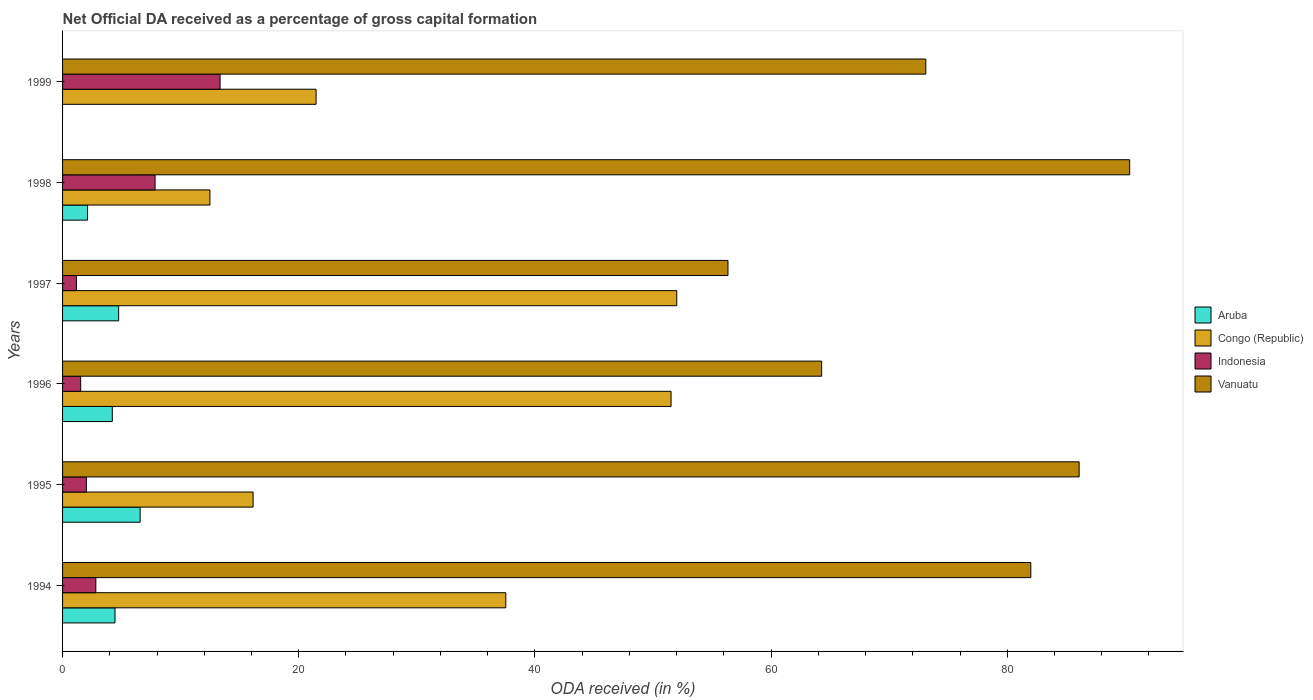How many bars are there on the 4th tick from the bottom?
Provide a short and direct response. 4. In how many cases, is the number of bars for a given year not equal to the number of legend labels?
Your answer should be compact. 1. What is the net ODA received in Indonesia in 1995?
Your answer should be very brief. 2.02. Across all years, what is the maximum net ODA received in Vanuatu?
Ensure brevity in your answer.  90.36. Across all years, what is the minimum net ODA received in Indonesia?
Provide a short and direct response. 1.18. What is the total net ODA received in Aruba in the graph?
Your response must be concise. 22.09. What is the difference between the net ODA received in Aruba in 1995 and that in 1996?
Your answer should be very brief. 2.36. What is the difference between the net ODA received in Aruba in 1995 and the net ODA received in Vanuatu in 1997?
Provide a succinct answer. -49.78. What is the average net ODA received in Vanuatu per year?
Ensure brevity in your answer.  75.36. In the year 1995, what is the difference between the net ODA received in Congo (Republic) and net ODA received in Vanuatu?
Give a very brief answer. -69.95. In how many years, is the net ODA received in Indonesia greater than 52 %?
Provide a succinct answer. 0. What is the ratio of the net ODA received in Congo (Republic) in 1995 to that in 1999?
Keep it short and to the point. 0.75. Is the net ODA received in Vanuatu in 1994 less than that in 1997?
Your answer should be very brief. No. Is the difference between the net ODA received in Congo (Republic) in 1994 and 1995 greater than the difference between the net ODA received in Vanuatu in 1994 and 1995?
Your answer should be compact. Yes. What is the difference between the highest and the second highest net ODA received in Vanuatu?
Make the answer very short. 4.28. What is the difference between the highest and the lowest net ODA received in Congo (Republic)?
Your response must be concise. 39.53. In how many years, is the net ODA received in Aruba greater than the average net ODA received in Aruba taken over all years?
Provide a succinct answer. 4. Is it the case that in every year, the sum of the net ODA received in Vanuatu and net ODA received in Aruba is greater than the net ODA received in Congo (Republic)?
Your response must be concise. Yes. Are all the bars in the graph horizontal?
Offer a very short reply. Yes. How many years are there in the graph?
Offer a very short reply. 6. Does the graph contain any zero values?
Give a very brief answer. Yes. Where does the legend appear in the graph?
Make the answer very short. Center right. How are the legend labels stacked?
Make the answer very short. Vertical. What is the title of the graph?
Your answer should be compact. Net Official DA received as a percentage of gross capital formation. What is the label or title of the X-axis?
Make the answer very short. ODA received (in %). What is the label or title of the Y-axis?
Your answer should be compact. Years. What is the ODA received (in %) of Aruba in 1994?
Provide a succinct answer. 4.44. What is the ODA received (in %) in Congo (Republic) in 1994?
Ensure brevity in your answer.  37.53. What is the ODA received (in %) in Indonesia in 1994?
Provide a succinct answer. 2.82. What is the ODA received (in %) in Vanuatu in 1994?
Make the answer very short. 81.99. What is the ODA received (in %) in Aruba in 1995?
Provide a succinct answer. 6.57. What is the ODA received (in %) of Congo (Republic) in 1995?
Offer a very short reply. 16.13. What is the ODA received (in %) in Indonesia in 1995?
Your response must be concise. 2.02. What is the ODA received (in %) in Vanuatu in 1995?
Offer a terse response. 86.09. What is the ODA received (in %) of Aruba in 1996?
Offer a terse response. 4.21. What is the ODA received (in %) of Congo (Republic) in 1996?
Make the answer very short. 51.53. What is the ODA received (in %) in Indonesia in 1996?
Make the answer very short. 1.53. What is the ODA received (in %) in Vanuatu in 1996?
Give a very brief answer. 64.28. What is the ODA received (in %) of Aruba in 1997?
Make the answer very short. 4.75. What is the ODA received (in %) in Congo (Republic) in 1997?
Ensure brevity in your answer.  52.01. What is the ODA received (in %) of Indonesia in 1997?
Ensure brevity in your answer.  1.18. What is the ODA received (in %) in Vanuatu in 1997?
Your answer should be very brief. 56.35. What is the ODA received (in %) in Aruba in 1998?
Give a very brief answer. 2.12. What is the ODA received (in %) in Congo (Republic) in 1998?
Offer a very short reply. 12.48. What is the ODA received (in %) of Indonesia in 1998?
Ensure brevity in your answer.  7.83. What is the ODA received (in %) of Vanuatu in 1998?
Your answer should be compact. 90.36. What is the ODA received (in %) of Congo (Republic) in 1999?
Keep it short and to the point. 21.47. What is the ODA received (in %) of Indonesia in 1999?
Offer a very short reply. 13.34. What is the ODA received (in %) of Vanuatu in 1999?
Make the answer very short. 73.1. Across all years, what is the maximum ODA received (in %) in Aruba?
Provide a short and direct response. 6.57. Across all years, what is the maximum ODA received (in %) of Congo (Republic)?
Provide a short and direct response. 52.01. Across all years, what is the maximum ODA received (in %) of Indonesia?
Your answer should be very brief. 13.34. Across all years, what is the maximum ODA received (in %) of Vanuatu?
Give a very brief answer. 90.36. Across all years, what is the minimum ODA received (in %) of Aruba?
Your answer should be compact. 0. Across all years, what is the minimum ODA received (in %) in Congo (Republic)?
Your answer should be very brief. 12.48. Across all years, what is the minimum ODA received (in %) in Indonesia?
Ensure brevity in your answer.  1.18. Across all years, what is the minimum ODA received (in %) in Vanuatu?
Provide a short and direct response. 56.35. What is the total ODA received (in %) in Aruba in the graph?
Your response must be concise. 22.09. What is the total ODA received (in %) in Congo (Republic) in the graph?
Your response must be concise. 191.15. What is the total ODA received (in %) of Indonesia in the graph?
Your answer should be compact. 28.72. What is the total ODA received (in %) in Vanuatu in the graph?
Offer a terse response. 452.17. What is the difference between the ODA received (in %) of Aruba in 1994 and that in 1995?
Give a very brief answer. -2.13. What is the difference between the ODA received (in %) of Congo (Republic) in 1994 and that in 1995?
Keep it short and to the point. 21.4. What is the difference between the ODA received (in %) of Indonesia in 1994 and that in 1995?
Offer a terse response. 0.8. What is the difference between the ODA received (in %) of Vanuatu in 1994 and that in 1995?
Provide a short and direct response. -4.09. What is the difference between the ODA received (in %) in Aruba in 1994 and that in 1996?
Keep it short and to the point. 0.23. What is the difference between the ODA received (in %) of Congo (Republic) in 1994 and that in 1996?
Your answer should be compact. -13.99. What is the difference between the ODA received (in %) of Indonesia in 1994 and that in 1996?
Your answer should be compact. 1.28. What is the difference between the ODA received (in %) in Vanuatu in 1994 and that in 1996?
Your answer should be compact. 17.71. What is the difference between the ODA received (in %) in Aruba in 1994 and that in 1997?
Provide a succinct answer. -0.31. What is the difference between the ODA received (in %) in Congo (Republic) in 1994 and that in 1997?
Make the answer very short. -14.48. What is the difference between the ODA received (in %) of Indonesia in 1994 and that in 1997?
Provide a succinct answer. 1.64. What is the difference between the ODA received (in %) of Vanuatu in 1994 and that in 1997?
Offer a very short reply. 25.64. What is the difference between the ODA received (in %) in Aruba in 1994 and that in 1998?
Offer a very short reply. 2.32. What is the difference between the ODA received (in %) of Congo (Republic) in 1994 and that in 1998?
Give a very brief answer. 25.06. What is the difference between the ODA received (in %) in Indonesia in 1994 and that in 1998?
Provide a short and direct response. -5.01. What is the difference between the ODA received (in %) in Vanuatu in 1994 and that in 1998?
Ensure brevity in your answer.  -8.37. What is the difference between the ODA received (in %) in Congo (Republic) in 1994 and that in 1999?
Give a very brief answer. 16.06. What is the difference between the ODA received (in %) in Indonesia in 1994 and that in 1999?
Make the answer very short. -10.52. What is the difference between the ODA received (in %) in Vanuatu in 1994 and that in 1999?
Provide a succinct answer. 8.89. What is the difference between the ODA received (in %) in Aruba in 1995 and that in 1996?
Your answer should be very brief. 2.36. What is the difference between the ODA received (in %) of Congo (Republic) in 1995 and that in 1996?
Your answer should be very brief. -35.39. What is the difference between the ODA received (in %) in Indonesia in 1995 and that in 1996?
Ensure brevity in your answer.  0.48. What is the difference between the ODA received (in %) of Vanuatu in 1995 and that in 1996?
Make the answer very short. 21.81. What is the difference between the ODA received (in %) of Aruba in 1995 and that in 1997?
Offer a very short reply. 1.82. What is the difference between the ODA received (in %) in Congo (Republic) in 1995 and that in 1997?
Your answer should be compact. -35.88. What is the difference between the ODA received (in %) in Indonesia in 1995 and that in 1997?
Offer a very short reply. 0.84. What is the difference between the ODA received (in %) of Vanuatu in 1995 and that in 1997?
Your answer should be very brief. 29.74. What is the difference between the ODA received (in %) in Aruba in 1995 and that in 1998?
Provide a succinct answer. 4.45. What is the difference between the ODA received (in %) of Congo (Republic) in 1995 and that in 1998?
Your answer should be compact. 3.66. What is the difference between the ODA received (in %) in Indonesia in 1995 and that in 1998?
Keep it short and to the point. -5.82. What is the difference between the ODA received (in %) in Vanuatu in 1995 and that in 1998?
Your response must be concise. -4.28. What is the difference between the ODA received (in %) of Congo (Republic) in 1995 and that in 1999?
Give a very brief answer. -5.33. What is the difference between the ODA received (in %) of Indonesia in 1995 and that in 1999?
Your response must be concise. -11.32. What is the difference between the ODA received (in %) in Vanuatu in 1995 and that in 1999?
Your answer should be compact. 12.98. What is the difference between the ODA received (in %) of Aruba in 1996 and that in 1997?
Provide a short and direct response. -0.54. What is the difference between the ODA received (in %) of Congo (Republic) in 1996 and that in 1997?
Offer a terse response. -0.48. What is the difference between the ODA received (in %) in Indonesia in 1996 and that in 1997?
Keep it short and to the point. 0.36. What is the difference between the ODA received (in %) in Vanuatu in 1996 and that in 1997?
Offer a terse response. 7.93. What is the difference between the ODA received (in %) in Aruba in 1996 and that in 1998?
Your answer should be compact. 2.1. What is the difference between the ODA received (in %) of Congo (Republic) in 1996 and that in 1998?
Keep it short and to the point. 39.05. What is the difference between the ODA received (in %) of Indonesia in 1996 and that in 1998?
Provide a short and direct response. -6.3. What is the difference between the ODA received (in %) of Vanuatu in 1996 and that in 1998?
Provide a succinct answer. -26.08. What is the difference between the ODA received (in %) in Congo (Republic) in 1996 and that in 1999?
Ensure brevity in your answer.  30.06. What is the difference between the ODA received (in %) in Indonesia in 1996 and that in 1999?
Provide a short and direct response. -11.8. What is the difference between the ODA received (in %) in Vanuatu in 1996 and that in 1999?
Make the answer very short. -8.82. What is the difference between the ODA received (in %) in Aruba in 1997 and that in 1998?
Offer a terse response. 2.63. What is the difference between the ODA received (in %) of Congo (Republic) in 1997 and that in 1998?
Keep it short and to the point. 39.53. What is the difference between the ODA received (in %) of Indonesia in 1997 and that in 1998?
Make the answer very short. -6.66. What is the difference between the ODA received (in %) in Vanuatu in 1997 and that in 1998?
Provide a short and direct response. -34.02. What is the difference between the ODA received (in %) of Congo (Republic) in 1997 and that in 1999?
Offer a terse response. 30.54. What is the difference between the ODA received (in %) of Indonesia in 1997 and that in 1999?
Your answer should be very brief. -12.16. What is the difference between the ODA received (in %) of Vanuatu in 1997 and that in 1999?
Make the answer very short. -16.76. What is the difference between the ODA received (in %) of Congo (Republic) in 1998 and that in 1999?
Your answer should be very brief. -8.99. What is the difference between the ODA received (in %) in Indonesia in 1998 and that in 1999?
Offer a terse response. -5.5. What is the difference between the ODA received (in %) of Vanuatu in 1998 and that in 1999?
Give a very brief answer. 17.26. What is the difference between the ODA received (in %) in Aruba in 1994 and the ODA received (in %) in Congo (Republic) in 1995?
Provide a succinct answer. -11.69. What is the difference between the ODA received (in %) in Aruba in 1994 and the ODA received (in %) in Indonesia in 1995?
Your answer should be compact. 2.42. What is the difference between the ODA received (in %) of Aruba in 1994 and the ODA received (in %) of Vanuatu in 1995?
Give a very brief answer. -81.64. What is the difference between the ODA received (in %) of Congo (Republic) in 1994 and the ODA received (in %) of Indonesia in 1995?
Provide a succinct answer. 35.52. What is the difference between the ODA received (in %) of Congo (Republic) in 1994 and the ODA received (in %) of Vanuatu in 1995?
Provide a succinct answer. -48.55. What is the difference between the ODA received (in %) in Indonesia in 1994 and the ODA received (in %) in Vanuatu in 1995?
Your answer should be compact. -83.27. What is the difference between the ODA received (in %) in Aruba in 1994 and the ODA received (in %) in Congo (Republic) in 1996?
Offer a very short reply. -47.09. What is the difference between the ODA received (in %) of Aruba in 1994 and the ODA received (in %) of Indonesia in 1996?
Offer a terse response. 2.91. What is the difference between the ODA received (in %) in Aruba in 1994 and the ODA received (in %) in Vanuatu in 1996?
Provide a succinct answer. -59.84. What is the difference between the ODA received (in %) of Congo (Republic) in 1994 and the ODA received (in %) of Indonesia in 1996?
Offer a terse response. 36. What is the difference between the ODA received (in %) in Congo (Republic) in 1994 and the ODA received (in %) in Vanuatu in 1996?
Provide a short and direct response. -26.75. What is the difference between the ODA received (in %) of Indonesia in 1994 and the ODA received (in %) of Vanuatu in 1996?
Your answer should be very brief. -61.46. What is the difference between the ODA received (in %) of Aruba in 1994 and the ODA received (in %) of Congo (Republic) in 1997?
Provide a short and direct response. -47.57. What is the difference between the ODA received (in %) of Aruba in 1994 and the ODA received (in %) of Indonesia in 1997?
Ensure brevity in your answer.  3.27. What is the difference between the ODA received (in %) of Aruba in 1994 and the ODA received (in %) of Vanuatu in 1997?
Offer a very short reply. -51.91. What is the difference between the ODA received (in %) of Congo (Republic) in 1994 and the ODA received (in %) of Indonesia in 1997?
Make the answer very short. 36.36. What is the difference between the ODA received (in %) in Congo (Republic) in 1994 and the ODA received (in %) in Vanuatu in 1997?
Provide a short and direct response. -18.81. What is the difference between the ODA received (in %) in Indonesia in 1994 and the ODA received (in %) in Vanuatu in 1997?
Your response must be concise. -53.53. What is the difference between the ODA received (in %) of Aruba in 1994 and the ODA received (in %) of Congo (Republic) in 1998?
Make the answer very short. -8.04. What is the difference between the ODA received (in %) in Aruba in 1994 and the ODA received (in %) in Indonesia in 1998?
Ensure brevity in your answer.  -3.39. What is the difference between the ODA received (in %) of Aruba in 1994 and the ODA received (in %) of Vanuatu in 1998?
Provide a succinct answer. -85.92. What is the difference between the ODA received (in %) in Congo (Republic) in 1994 and the ODA received (in %) in Indonesia in 1998?
Make the answer very short. 29.7. What is the difference between the ODA received (in %) of Congo (Republic) in 1994 and the ODA received (in %) of Vanuatu in 1998?
Your answer should be compact. -52.83. What is the difference between the ODA received (in %) in Indonesia in 1994 and the ODA received (in %) in Vanuatu in 1998?
Provide a succinct answer. -87.54. What is the difference between the ODA received (in %) of Aruba in 1994 and the ODA received (in %) of Congo (Republic) in 1999?
Ensure brevity in your answer.  -17.03. What is the difference between the ODA received (in %) in Aruba in 1994 and the ODA received (in %) in Indonesia in 1999?
Provide a short and direct response. -8.9. What is the difference between the ODA received (in %) in Aruba in 1994 and the ODA received (in %) in Vanuatu in 1999?
Provide a succinct answer. -68.66. What is the difference between the ODA received (in %) in Congo (Republic) in 1994 and the ODA received (in %) in Indonesia in 1999?
Ensure brevity in your answer.  24.2. What is the difference between the ODA received (in %) in Congo (Republic) in 1994 and the ODA received (in %) in Vanuatu in 1999?
Give a very brief answer. -35.57. What is the difference between the ODA received (in %) of Indonesia in 1994 and the ODA received (in %) of Vanuatu in 1999?
Ensure brevity in your answer.  -70.28. What is the difference between the ODA received (in %) of Aruba in 1995 and the ODA received (in %) of Congo (Republic) in 1996?
Your answer should be compact. -44.96. What is the difference between the ODA received (in %) in Aruba in 1995 and the ODA received (in %) in Indonesia in 1996?
Give a very brief answer. 5.04. What is the difference between the ODA received (in %) in Aruba in 1995 and the ODA received (in %) in Vanuatu in 1996?
Ensure brevity in your answer.  -57.71. What is the difference between the ODA received (in %) of Congo (Republic) in 1995 and the ODA received (in %) of Indonesia in 1996?
Your response must be concise. 14.6. What is the difference between the ODA received (in %) in Congo (Republic) in 1995 and the ODA received (in %) in Vanuatu in 1996?
Give a very brief answer. -48.15. What is the difference between the ODA received (in %) in Indonesia in 1995 and the ODA received (in %) in Vanuatu in 1996?
Your answer should be compact. -62.26. What is the difference between the ODA received (in %) in Aruba in 1995 and the ODA received (in %) in Congo (Republic) in 1997?
Make the answer very short. -45.44. What is the difference between the ODA received (in %) in Aruba in 1995 and the ODA received (in %) in Indonesia in 1997?
Offer a very short reply. 5.39. What is the difference between the ODA received (in %) in Aruba in 1995 and the ODA received (in %) in Vanuatu in 1997?
Your response must be concise. -49.78. What is the difference between the ODA received (in %) of Congo (Republic) in 1995 and the ODA received (in %) of Indonesia in 1997?
Your answer should be very brief. 14.96. What is the difference between the ODA received (in %) of Congo (Republic) in 1995 and the ODA received (in %) of Vanuatu in 1997?
Offer a terse response. -40.21. What is the difference between the ODA received (in %) of Indonesia in 1995 and the ODA received (in %) of Vanuatu in 1997?
Offer a terse response. -54.33. What is the difference between the ODA received (in %) in Aruba in 1995 and the ODA received (in %) in Congo (Republic) in 1998?
Keep it short and to the point. -5.91. What is the difference between the ODA received (in %) of Aruba in 1995 and the ODA received (in %) of Indonesia in 1998?
Your answer should be compact. -1.26. What is the difference between the ODA received (in %) of Aruba in 1995 and the ODA received (in %) of Vanuatu in 1998?
Ensure brevity in your answer.  -83.79. What is the difference between the ODA received (in %) of Congo (Republic) in 1995 and the ODA received (in %) of Indonesia in 1998?
Provide a short and direct response. 8.3. What is the difference between the ODA received (in %) in Congo (Republic) in 1995 and the ODA received (in %) in Vanuatu in 1998?
Your response must be concise. -74.23. What is the difference between the ODA received (in %) of Indonesia in 1995 and the ODA received (in %) of Vanuatu in 1998?
Provide a short and direct response. -88.35. What is the difference between the ODA received (in %) of Aruba in 1995 and the ODA received (in %) of Congo (Republic) in 1999?
Your answer should be very brief. -14.9. What is the difference between the ODA received (in %) of Aruba in 1995 and the ODA received (in %) of Indonesia in 1999?
Your answer should be compact. -6.77. What is the difference between the ODA received (in %) of Aruba in 1995 and the ODA received (in %) of Vanuatu in 1999?
Give a very brief answer. -66.53. What is the difference between the ODA received (in %) of Congo (Republic) in 1995 and the ODA received (in %) of Indonesia in 1999?
Your answer should be very brief. 2.8. What is the difference between the ODA received (in %) of Congo (Republic) in 1995 and the ODA received (in %) of Vanuatu in 1999?
Your answer should be compact. -56.97. What is the difference between the ODA received (in %) in Indonesia in 1995 and the ODA received (in %) in Vanuatu in 1999?
Offer a terse response. -71.09. What is the difference between the ODA received (in %) in Aruba in 1996 and the ODA received (in %) in Congo (Republic) in 1997?
Your answer should be very brief. -47.8. What is the difference between the ODA received (in %) of Aruba in 1996 and the ODA received (in %) of Indonesia in 1997?
Provide a succinct answer. 3.04. What is the difference between the ODA received (in %) in Aruba in 1996 and the ODA received (in %) in Vanuatu in 1997?
Offer a terse response. -52.14. What is the difference between the ODA received (in %) in Congo (Republic) in 1996 and the ODA received (in %) in Indonesia in 1997?
Provide a succinct answer. 50.35. What is the difference between the ODA received (in %) of Congo (Republic) in 1996 and the ODA received (in %) of Vanuatu in 1997?
Ensure brevity in your answer.  -4.82. What is the difference between the ODA received (in %) in Indonesia in 1996 and the ODA received (in %) in Vanuatu in 1997?
Offer a very short reply. -54.81. What is the difference between the ODA received (in %) of Aruba in 1996 and the ODA received (in %) of Congo (Republic) in 1998?
Provide a succinct answer. -8.27. What is the difference between the ODA received (in %) of Aruba in 1996 and the ODA received (in %) of Indonesia in 1998?
Keep it short and to the point. -3.62. What is the difference between the ODA received (in %) in Aruba in 1996 and the ODA received (in %) in Vanuatu in 1998?
Provide a short and direct response. -86.15. What is the difference between the ODA received (in %) in Congo (Republic) in 1996 and the ODA received (in %) in Indonesia in 1998?
Keep it short and to the point. 43.7. What is the difference between the ODA received (in %) in Congo (Republic) in 1996 and the ODA received (in %) in Vanuatu in 1998?
Offer a very short reply. -38.83. What is the difference between the ODA received (in %) of Indonesia in 1996 and the ODA received (in %) of Vanuatu in 1998?
Offer a terse response. -88.83. What is the difference between the ODA received (in %) in Aruba in 1996 and the ODA received (in %) in Congo (Republic) in 1999?
Keep it short and to the point. -17.26. What is the difference between the ODA received (in %) in Aruba in 1996 and the ODA received (in %) in Indonesia in 1999?
Make the answer very short. -9.13. What is the difference between the ODA received (in %) of Aruba in 1996 and the ODA received (in %) of Vanuatu in 1999?
Ensure brevity in your answer.  -68.89. What is the difference between the ODA received (in %) of Congo (Republic) in 1996 and the ODA received (in %) of Indonesia in 1999?
Make the answer very short. 38.19. What is the difference between the ODA received (in %) of Congo (Republic) in 1996 and the ODA received (in %) of Vanuatu in 1999?
Offer a terse response. -21.57. What is the difference between the ODA received (in %) in Indonesia in 1996 and the ODA received (in %) in Vanuatu in 1999?
Make the answer very short. -71.57. What is the difference between the ODA received (in %) of Aruba in 1997 and the ODA received (in %) of Congo (Republic) in 1998?
Ensure brevity in your answer.  -7.73. What is the difference between the ODA received (in %) of Aruba in 1997 and the ODA received (in %) of Indonesia in 1998?
Make the answer very short. -3.08. What is the difference between the ODA received (in %) of Aruba in 1997 and the ODA received (in %) of Vanuatu in 1998?
Keep it short and to the point. -85.61. What is the difference between the ODA received (in %) of Congo (Republic) in 1997 and the ODA received (in %) of Indonesia in 1998?
Your answer should be compact. 44.18. What is the difference between the ODA received (in %) in Congo (Republic) in 1997 and the ODA received (in %) in Vanuatu in 1998?
Make the answer very short. -38.35. What is the difference between the ODA received (in %) of Indonesia in 1997 and the ODA received (in %) of Vanuatu in 1998?
Your answer should be very brief. -89.19. What is the difference between the ODA received (in %) of Aruba in 1997 and the ODA received (in %) of Congo (Republic) in 1999?
Your answer should be very brief. -16.72. What is the difference between the ODA received (in %) in Aruba in 1997 and the ODA received (in %) in Indonesia in 1999?
Provide a short and direct response. -8.59. What is the difference between the ODA received (in %) in Aruba in 1997 and the ODA received (in %) in Vanuatu in 1999?
Offer a terse response. -68.35. What is the difference between the ODA received (in %) of Congo (Republic) in 1997 and the ODA received (in %) of Indonesia in 1999?
Provide a short and direct response. 38.67. What is the difference between the ODA received (in %) in Congo (Republic) in 1997 and the ODA received (in %) in Vanuatu in 1999?
Make the answer very short. -21.09. What is the difference between the ODA received (in %) in Indonesia in 1997 and the ODA received (in %) in Vanuatu in 1999?
Keep it short and to the point. -71.93. What is the difference between the ODA received (in %) in Aruba in 1998 and the ODA received (in %) in Congo (Republic) in 1999?
Ensure brevity in your answer.  -19.35. What is the difference between the ODA received (in %) of Aruba in 1998 and the ODA received (in %) of Indonesia in 1999?
Give a very brief answer. -11.22. What is the difference between the ODA received (in %) of Aruba in 1998 and the ODA received (in %) of Vanuatu in 1999?
Offer a terse response. -70.99. What is the difference between the ODA received (in %) in Congo (Republic) in 1998 and the ODA received (in %) in Indonesia in 1999?
Your response must be concise. -0.86. What is the difference between the ODA received (in %) in Congo (Republic) in 1998 and the ODA received (in %) in Vanuatu in 1999?
Your answer should be compact. -60.63. What is the difference between the ODA received (in %) of Indonesia in 1998 and the ODA received (in %) of Vanuatu in 1999?
Give a very brief answer. -65.27. What is the average ODA received (in %) of Aruba per year?
Offer a terse response. 3.68. What is the average ODA received (in %) of Congo (Republic) per year?
Give a very brief answer. 31.86. What is the average ODA received (in %) of Indonesia per year?
Give a very brief answer. 4.79. What is the average ODA received (in %) in Vanuatu per year?
Your answer should be very brief. 75.36. In the year 1994, what is the difference between the ODA received (in %) of Aruba and ODA received (in %) of Congo (Republic)?
Offer a terse response. -33.09. In the year 1994, what is the difference between the ODA received (in %) of Aruba and ODA received (in %) of Indonesia?
Make the answer very short. 1.62. In the year 1994, what is the difference between the ODA received (in %) of Aruba and ODA received (in %) of Vanuatu?
Provide a short and direct response. -77.55. In the year 1994, what is the difference between the ODA received (in %) of Congo (Republic) and ODA received (in %) of Indonesia?
Ensure brevity in your answer.  34.72. In the year 1994, what is the difference between the ODA received (in %) in Congo (Republic) and ODA received (in %) in Vanuatu?
Provide a succinct answer. -44.46. In the year 1994, what is the difference between the ODA received (in %) of Indonesia and ODA received (in %) of Vanuatu?
Offer a terse response. -79.17. In the year 1995, what is the difference between the ODA received (in %) of Aruba and ODA received (in %) of Congo (Republic)?
Provide a succinct answer. -9.56. In the year 1995, what is the difference between the ODA received (in %) in Aruba and ODA received (in %) in Indonesia?
Make the answer very short. 4.55. In the year 1995, what is the difference between the ODA received (in %) of Aruba and ODA received (in %) of Vanuatu?
Provide a short and direct response. -79.52. In the year 1995, what is the difference between the ODA received (in %) in Congo (Republic) and ODA received (in %) in Indonesia?
Offer a terse response. 14.12. In the year 1995, what is the difference between the ODA received (in %) of Congo (Republic) and ODA received (in %) of Vanuatu?
Your answer should be compact. -69.95. In the year 1995, what is the difference between the ODA received (in %) in Indonesia and ODA received (in %) in Vanuatu?
Your answer should be very brief. -84.07. In the year 1996, what is the difference between the ODA received (in %) of Aruba and ODA received (in %) of Congo (Republic)?
Keep it short and to the point. -47.32. In the year 1996, what is the difference between the ODA received (in %) in Aruba and ODA received (in %) in Indonesia?
Provide a short and direct response. 2.68. In the year 1996, what is the difference between the ODA received (in %) in Aruba and ODA received (in %) in Vanuatu?
Provide a short and direct response. -60.07. In the year 1996, what is the difference between the ODA received (in %) of Congo (Republic) and ODA received (in %) of Indonesia?
Give a very brief answer. 49.99. In the year 1996, what is the difference between the ODA received (in %) of Congo (Republic) and ODA received (in %) of Vanuatu?
Keep it short and to the point. -12.75. In the year 1996, what is the difference between the ODA received (in %) of Indonesia and ODA received (in %) of Vanuatu?
Your response must be concise. -62.75. In the year 1997, what is the difference between the ODA received (in %) in Aruba and ODA received (in %) in Congo (Republic)?
Ensure brevity in your answer.  -47.26. In the year 1997, what is the difference between the ODA received (in %) of Aruba and ODA received (in %) of Indonesia?
Provide a short and direct response. 3.57. In the year 1997, what is the difference between the ODA received (in %) in Aruba and ODA received (in %) in Vanuatu?
Ensure brevity in your answer.  -51.6. In the year 1997, what is the difference between the ODA received (in %) of Congo (Republic) and ODA received (in %) of Indonesia?
Your answer should be very brief. 50.83. In the year 1997, what is the difference between the ODA received (in %) in Congo (Republic) and ODA received (in %) in Vanuatu?
Make the answer very short. -4.34. In the year 1997, what is the difference between the ODA received (in %) of Indonesia and ODA received (in %) of Vanuatu?
Give a very brief answer. -55.17. In the year 1998, what is the difference between the ODA received (in %) in Aruba and ODA received (in %) in Congo (Republic)?
Give a very brief answer. -10.36. In the year 1998, what is the difference between the ODA received (in %) of Aruba and ODA received (in %) of Indonesia?
Keep it short and to the point. -5.72. In the year 1998, what is the difference between the ODA received (in %) of Aruba and ODA received (in %) of Vanuatu?
Offer a terse response. -88.25. In the year 1998, what is the difference between the ODA received (in %) of Congo (Republic) and ODA received (in %) of Indonesia?
Ensure brevity in your answer.  4.64. In the year 1998, what is the difference between the ODA received (in %) in Congo (Republic) and ODA received (in %) in Vanuatu?
Give a very brief answer. -77.89. In the year 1998, what is the difference between the ODA received (in %) in Indonesia and ODA received (in %) in Vanuatu?
Ensure brevity in your answer.  -82.53. In the year 1999, what is the difference between the ODA received (in %) in Congo (Republic) and ODA received (in %) in Indonesia?
Offer a terse response. 8.13. In the year 1999, what is the difference between the ODA received (in %) in Congo (Republic) and ODA received (in %) in Vanuatu?
Ensure brevity in your answer.  -51.63. In the year 1999, what is the difference between the ODA received (in %) in Indonesia and ODA received (in %) in Vanuatu?
Your response must be concise. -59.77. What is the ratio of the ODA received (in %) in Aruba in 1994 to that in 1995?
Keep it short and to the point. 0.68. What is the ratio of the ODA received (in %) in Congo (Republic) in 1994 to that in 1995?
Your response must be concise. 2.33. What is the ratio of the ODA received (in %) in Indonesia in 1994 to that in 1995?
Provide a succinct answer. 1.4. What is the ratio of the ODA received (in %) in Vanuatu in 1994 to that in 1995?
Give a very brief answer. 0.95. What is the ratio of the ODA received (in %) of Aruba in 1994 to that in 1996?
Provide a short and direct response. 1.05. What is the ratio of the ODA received (in %) of Congo (Republic) in 1994 to that in 1996?
Offer a very short reply. 0.73. What is the ratio of the ODA received (in %) in Indonesia in 1994 to that in 1996?
Offer a very short reply. 1.84. What is the ratio of the ODA received (in %) of Vanuatu in 1994 to that in 1996?
Offer a terse response. 1.28. What is the ratio of the ODA received (in %) in Aruba in 1994 to that in 1997?
Give a very brief answer. 0.94. What is the ratio of the ODA received (in %) in Congo (Republic) in 1994 to that in 1997?
Your response must be concise. 0.72. What is the ratio of the ODA received (in %) in Indonesia in 1994 to that in 1997?
Give a very brief answer. 2.4. What is the ratio of the ODA received (in %) of Vanuatu in 1994 to that in 1997?
Your response must be concise. 1.46. What is the ratio of the ODA received (in %) in Aruba in 1994 to that in 1998?
Make the answer very short. 2.1. What is the ratio of the ODA received (in %) of Congo (Republic) in 1994 to that in 1998?
Offer a terse response. 3.01. What is the ratio of the ODA received (in %) in Indonesia in 1994 to that in 1998?
Your response must be concise. 0.36. What is the ratio of the ODA received (in %) in Vanuatu in 1994 to that in 1998?
Make the answer very short. 0.91. What is the ratio of the ODA received (in %) in Congo (Republic) in 1994 to that in 1999?
Give a very brief answer. 1.75. What is the ratio of the ODA received (in %) in Indonesia in 1994 to that in 1999?
Your answer should be compact. 0.21. What is the ratio of the ODA received (in %) in Vanuatu in 1994 to that in 1999?
Make the answer very short. 1.12. What is the ratio of the ODA received (in %) in Aruba in 1995 to that in 1996?
Ensure brevity in your answer.  1.56. What is the ratio of the ODA received (in %) in Congo (Republic) in 1995 to that in 1996?
Offer a terse response. 0.31. What is the ratio of the ODA received (in %) in Indonesia in 1995 to that in 1996?
Your answer should be very brief. 1.31. What is the ratio of the ODA received (in %) of Vanuatu in 1995 to that in 1996?
Your answer should be compact. 1.34. What is the ratio of the ODA received (in %) of Aruba in 1995 to that in 1997?
Give a very brief answer. 1.38. What is the ratio of the ODA received (in %) of Congo (Republic) in 1995 to that in 1997?
Offer a very short reply. 0.31. What is the ratio of the ODA received (in %) of Indonesia in 1995 to that in 1997?
Make the answer very short. 1.71. What is the ratio of the ODA received (in %) of Vanuatu in 1995 to that in 1997?
Your answer should be compact. 1.53. What is the ratio of the ODA received (in %) in Aruba in 1995 to that in 1998?
Make the answer very short. 3.1. What is the ratio of the ODA received (in %) of Congo (Republic) in 1995 to that in 1998?
Provide a succinct answer. 1.29. What is the ratio of the ODA received (in %) in Indonesia in 1995 to that in 1998?
Your answer should be very brief. 0.26. What is the ratio of the ODA received (in %) in Vanuatu in 1995 to that in 1998?
Ensure brevity in your answer.  0.95. What is the ratio of the ODA received (in %) in Congo (Republic) in 1995 to that in 1999?
Keep it short and to the point. 0.75. What is the ratio of the ODA received (in %) of Indonesia in 1995 to that in 1999?
Provide a short and direct response. 0.15. What is the ratio of the ODA received (in %) of Vanuatu in 1995 to that in 1999?
Your answer should be very brief. 1.18. What is the ratio of the ODA received (in %) of Aruba in 1996 to that in 1997?
Provide a short and direct response. 0.89. What is the ratio of the ODA received (in %) in Congo (Republic) in 1996 to that in 1997?
Offer a terse response. 0.99. What is the ratio of the ODA received (in %) in Indonesia in 1996 to that in 1997?
Ensure brevity in your answer.  1.3. What is the ratio of the ODA received (in %) of Vanuatu in 1996 to that in 1997?
Make the answer very short. 1.14. What is the ratio of the ODA received (in %) of Aruba in 1996 to that in 1998?
Provide a succinct answer. 1.99. What is the ratio of the ODA received (in %) of Congo (Republic) in 1996 to that in 1998?
Provide a short and direct response. 4.13. What is the ratio of the ODA received (in %) in Indonesia in 1996 to that in 1998?
Keep it short and to the point. 0.2. What is the ratio of the ODA received (in %) of Vanuatu in 1996 to that in 1998?
Keep it short and to the point. 0.71. What is the ratio of the ODA received (in %) in Congo (Republic) in 1996 to that in 1999?
Your response must be concise. 2.4. What is the ratio of the ODA received (in %) in Indonesia in 1996 to that in 1999?
Ensure brevity in your answer.  0.12. What is the ratio of the ODA received (in %) of Vanuatu in 1996 to that in 1999?
Keep it short and to the point. 0.88. What is the ratio of the ODA received (in %) of Aruba in 1997 to that in 1998?
Give a very brief answer. 2.24. What is the ratio of the ODA received (in %) in Congo (Republic) in 1997 to that in 1998?
Make the answer very short. 4.17. What is the ratio of the ODA received (in %) in Indonesia in 1997 to that in 1998?
Provide a succinct answer. 0.15. What is the ratio of the ODA received (in %) in Vanuatu in 1997 to that in 1998?
Ensure brevity in your answer.  0.62. What is the ratio of the ODA received (in %) of Congo (Republic) in 1997 to that in 1999?
Ensure brevity in your answer.  2.42. What is the ratio of the ODA received (in %) in Indonesia in 1997 to that in 1999?
Your answer should be very brief. 0.09. What is the ratio of the ODA received (in %) of Vanuatu in 1997 to that in 1999?
Give a very brief answer. 0.77. What is the ratio of the ODA received (in %) in Congo (Republic) in 1998 to that in 1999?
Provide a succinct answer. 0.58. What is the ratio of the ODA received (in %) in Indonesia in 1998 to that in 1999?
Give a very brief answer. 0.59. What is the ratio of the ODA received (in %) in Vanuatu in 1998 to that in 1999?
Your answer should be very brief. 1.24. What is the difference between the highest and the second highest ODA received (in %) of Aruba?
Provide a succinct answer. 1.82. What is the difference between the highest and the second highest ODA received (in %) in Congo (Republic)?
Offer a very short reply. 0.48. What is the difference between the highest and the second highest ODA received (in %) of Indonesia?
Provide a succinct answer. 5.5. What is the difference between the highest and the second highest ODA received (in %) of Vanuatu?
Give a very brief answer. 4.28. What is the difference between the highest and the lowest ODA received (in %) in Aruba?
Provide a short and direct response. 6.57. What is the difference between the highest and the lowest ODA received (in %) of Congo (Republic)?
Provide a succinct answer. 39.53. What is the difference between the highest and the lowest ODA received (in %) of Indonesia?
Your response must be concise. 12.16. What is the difference between the highest and the lowest ODA received (in %) in Vanuatu?
Your response must be concise. 34.02. 